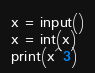<code> <loc_0><loc_0><loc_500><loc_500><_Python_>x = input()
x = int(x)
print(x^3)</code> 